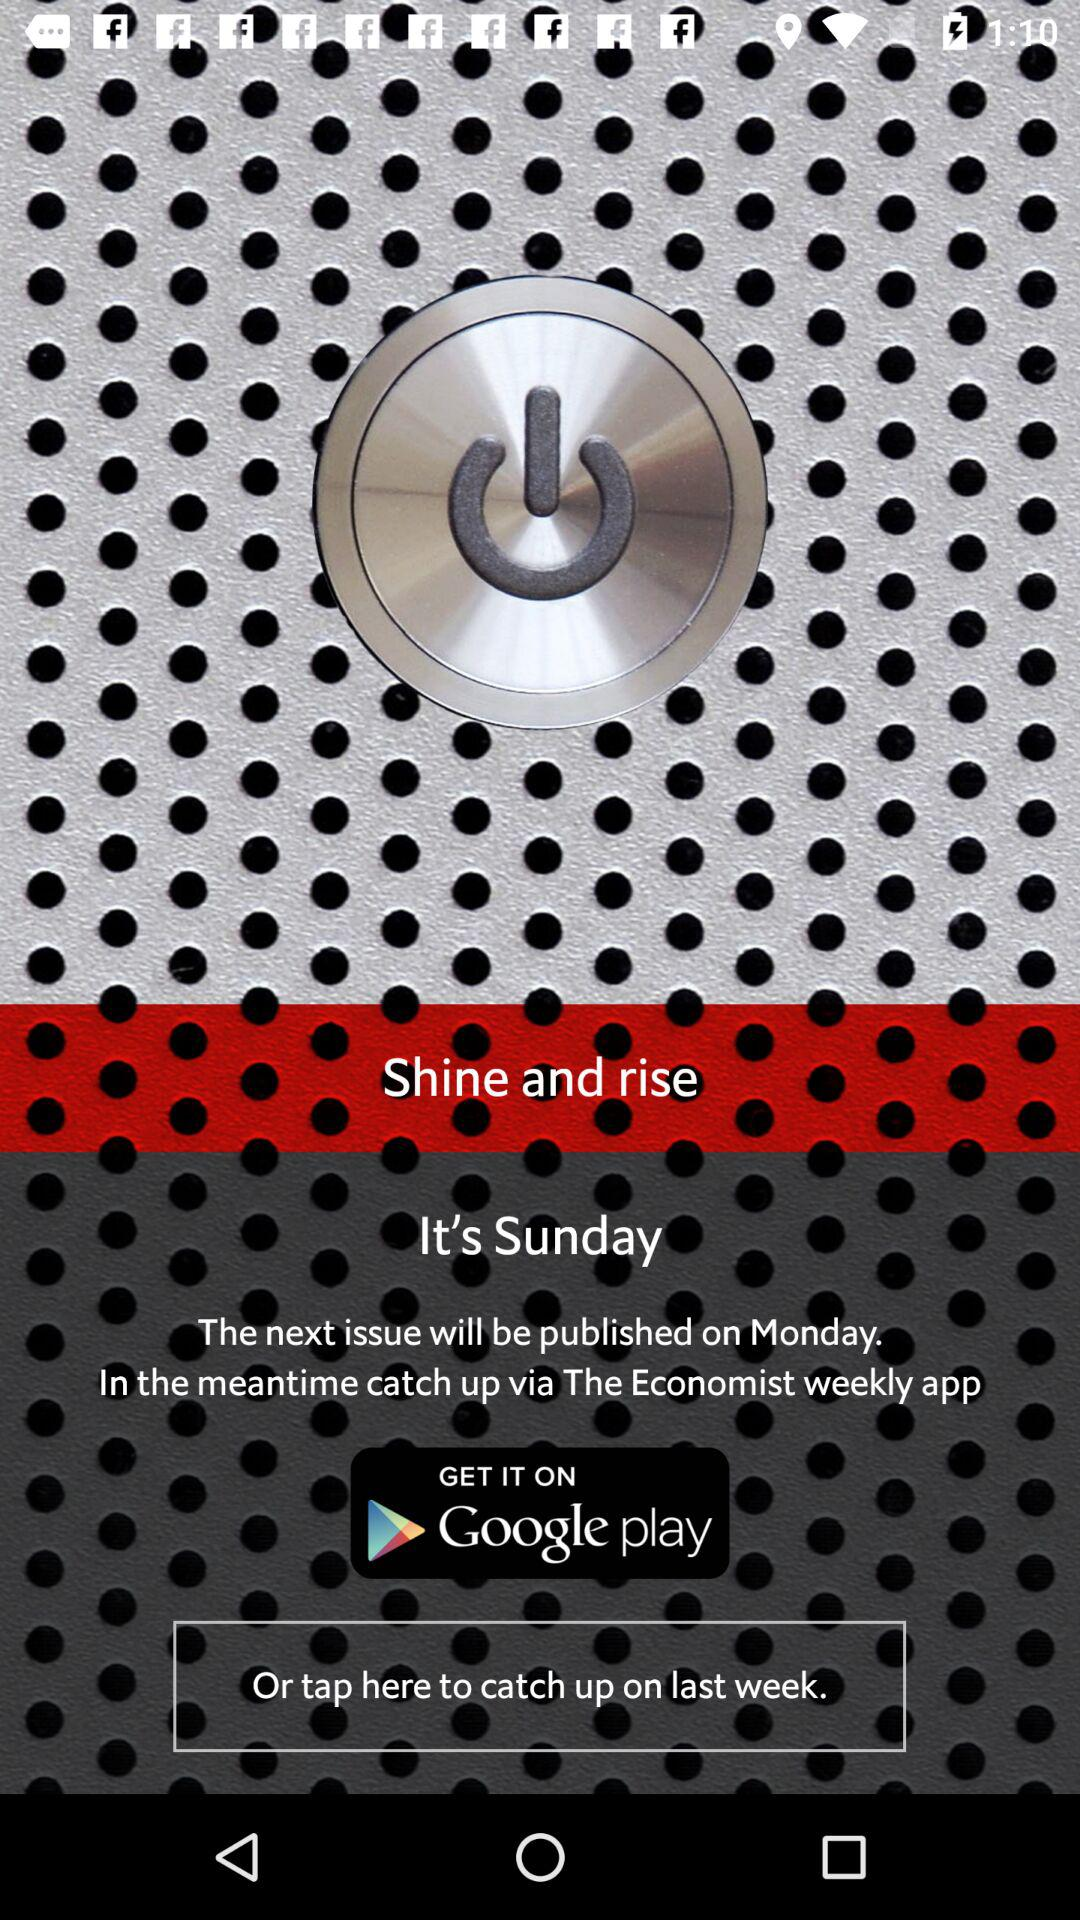What is the name of the application? The name of the application is "The Economist weekly". 